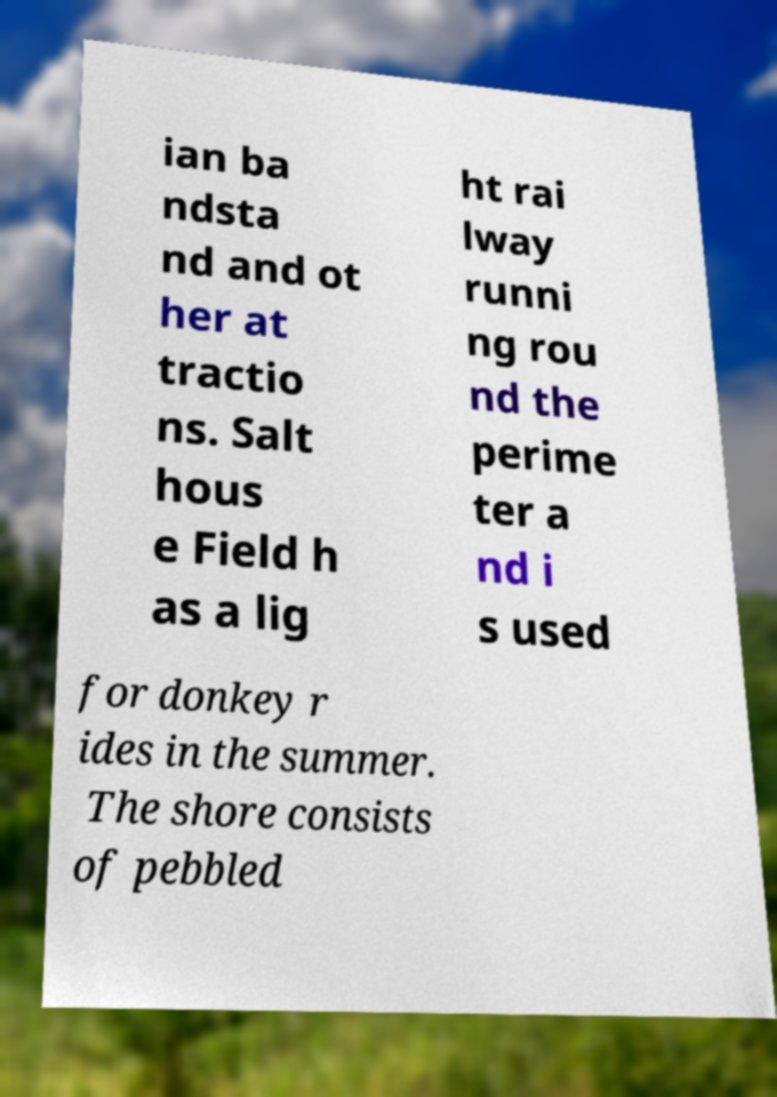Can you read and provide the text displayed in the image?This photo seems to have some interesting text. Can you extract and type it out for me? ian ba ndsta nd and ot her at tractio ns. Salt hous e Field h as a lig ht rai lway runni ng rou nd the perime ter a nd i s used for donkey r ides in the summer. The shore consists of pebbled 